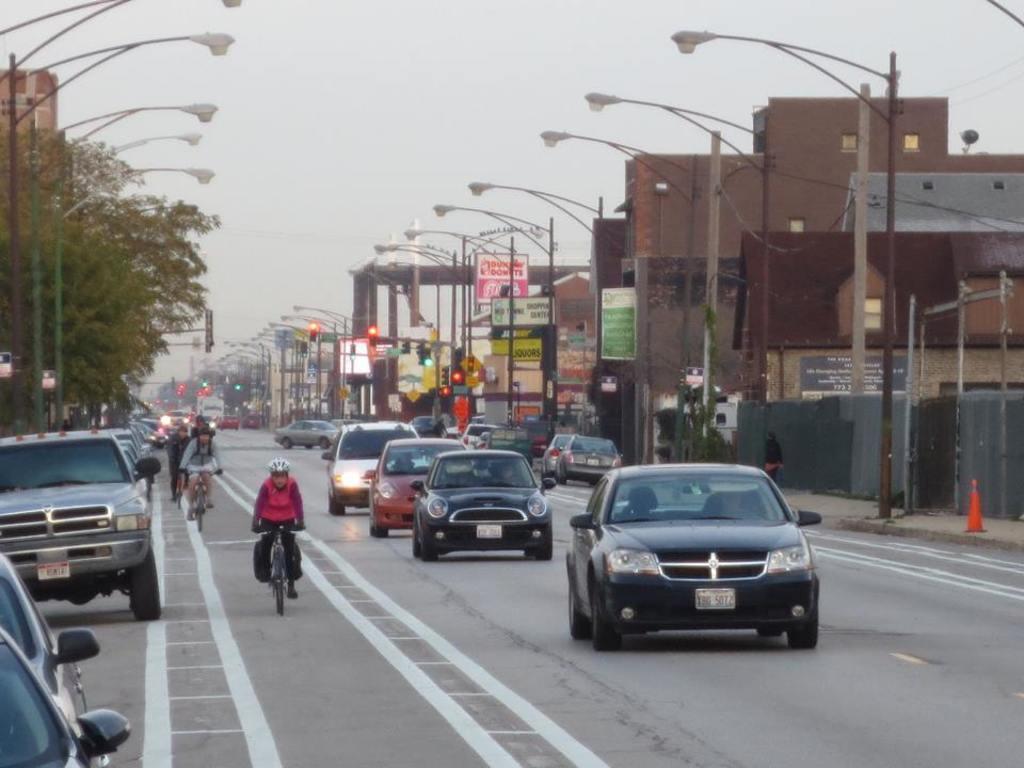Could you give a brief overview of what you see in this image? On the left side, there are vehicles on the road on which, there are white color line, persons cycling and there are vehicles. On both sides of this road, there are buildings and lights attached to the poles. In the background, there is sky. 